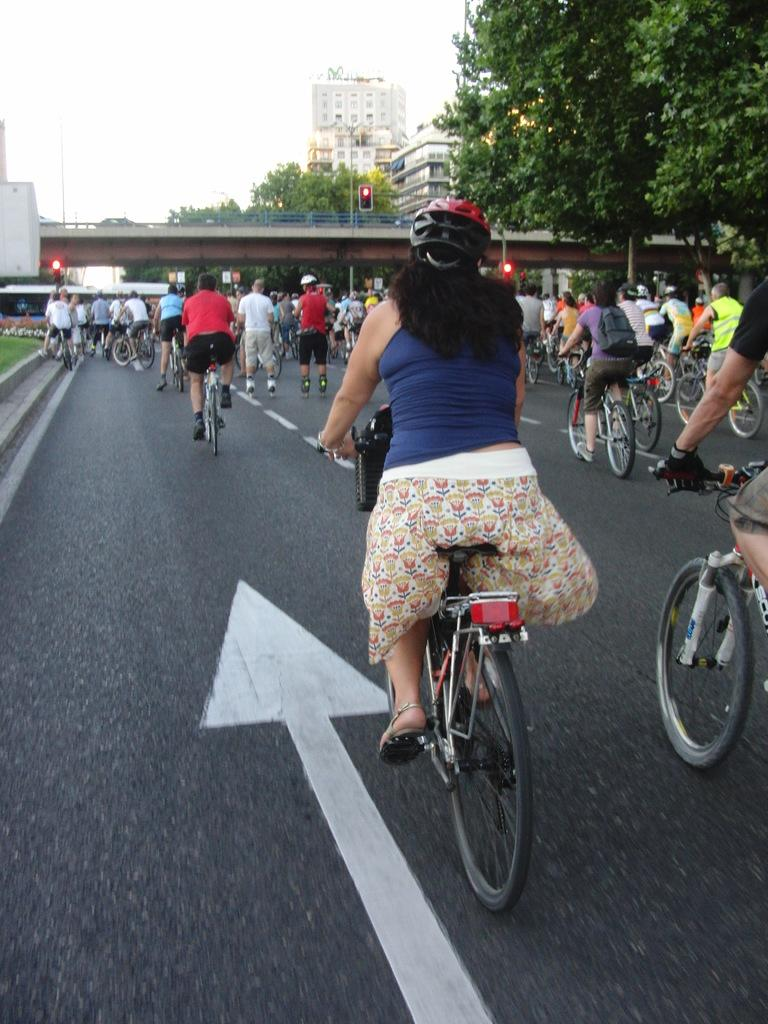What are the people in the image doing? The people in the image are riding bicycles. Where are the bicycles located? The bicycles are on a road. What else can be seen in the image besides the people and bicycles? There are buildings and trees visible in the image. What type of soda is being served at the houses in the image? There are no houses or soda present in the image; it features a group of people riding bicycles on a road with buildings and trees in the background. 